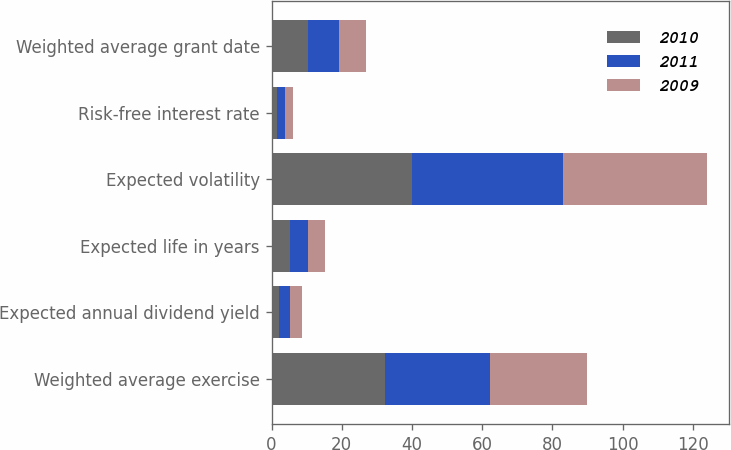Convert chart. <chart><loc_0><loc_0><loc_500><loc_500><stacked_bar_chart><ecel><fcel>Weighted average exercise<fcel>Expected annual dividend yield<fcel>Expected life in years<fcel>Expected volatility<fcel>Risk-free interest rate<fcel>Weighted average grant date<nl><fcel>2010<fcel>32.3<fcel>2.1<fcel>5.3<fcel>40<fcel>1.7<fcel>10.44<nl><fcel>2011<fcel>30<fcel>3.2<fcel>5.1<fcel>43<fcel>2.2<fcel>8.7<nl><fcel>2009<fcel>27.62<fcel>3.5<fcel>4.9<fcel>41<fcel>2.3<fcel>7.67<nl></chart> 